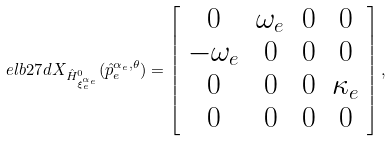Convert formula to latex. <formula><loc_0><loc_0><loc_500><loc_500>\ e l b { 2 7 } d X _ { \hat { H } _ { \xi ^ { \alpha _ { e } } _ { e } } ^ { 0 } } ( \hat { p } _ { e } ^ { \alpha _ { e } , \theta } ) = \left [ \begin{array} { c c c c } 0 & \omega _ { e } & 0 & 0 \\ - \omega _ { e } & 0 & 0 & 0 \\ 0 & 0 & 0 & \kappa _ { e } \\ 0 & 0 & 0 & 0 \end{array} \right ] ,</formula> 